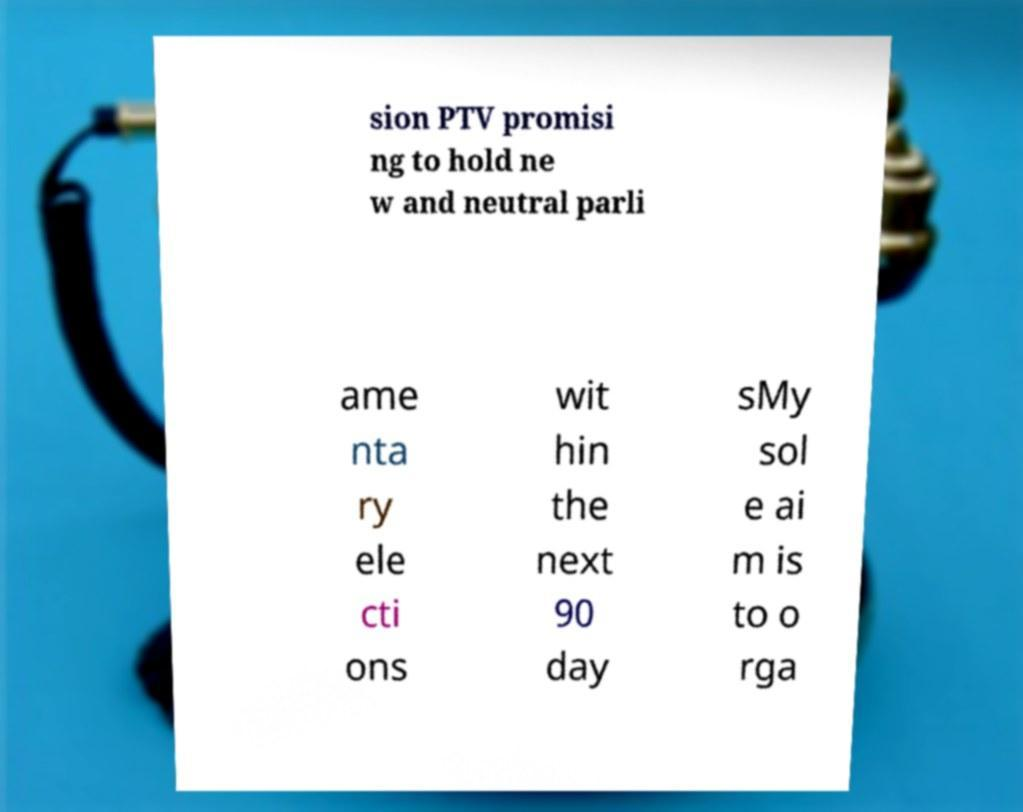Could you extract and type out the text from this image? sion PTV promisi ng to hold ne w and neutral parli ame nta ry ele cti ons wit hin the next 90 day sMy sol e ai m is to o rga 